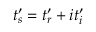Convert formula to latex. <formula><loc_0><loc_0><loc_500><loc_500>t _ { s } ^ { \prime } = t _ { r } ^ { \prime } + i t _ { i } ^ { \prime }</formula> 